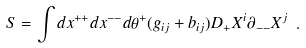Convert formula to latex. <formula><loc_0><loc_0><loc_500><loc_500>S = \int d x ^ { + + } d x ^ { - - } d \theta ^ { + } ( g _ { i j } + b _ { i j } ) D _ { + } X ^ { i } \partial _ { - - } X ^ { j } \ .</formula> 